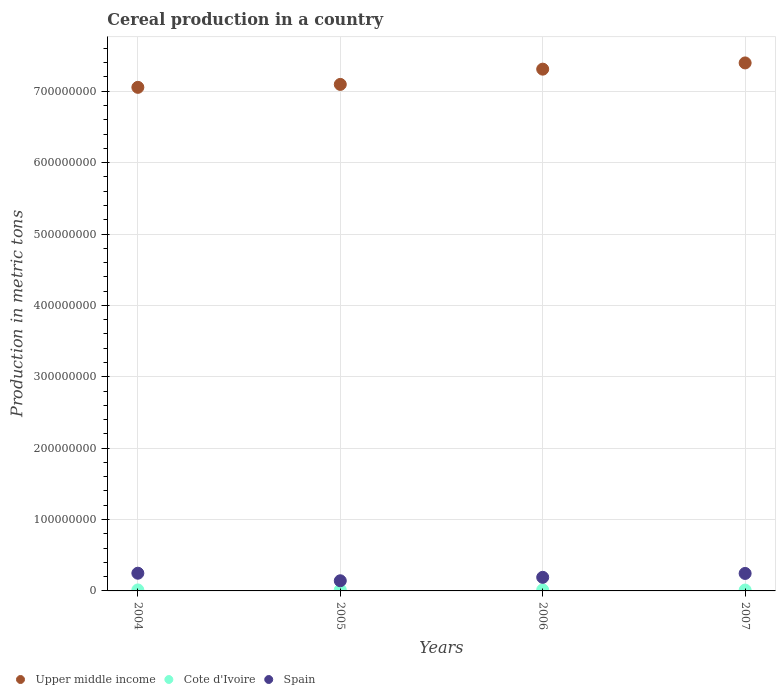What is the total cereal production in Upper middle income in 2005?
Provide a short and direct response. 7.10e+08. Across all years, what is the maximum total cereal production in Spain?
Offer a very short reply. 2.48e+07. Across all years, what is the minimum total cereal production in Spain?
Ensure brevity in your answer.  1.42e+07. In which year was the total cereal production in Upper middle income minimum?
Provide a short and direct response. 2004. What is the total total cereal production in Upper middle income in the graph?
Offer a very short reply. 2.89e+09. What is the difference between the total cereal production in Cote d'Ivoire in 2005 and that in 2007?
Give a very brief answer. 2.00e+05. What is the difference between the total cereal production in Upper middle income in 2004 and the total cereal production in Spain in 2005?
Your answer should be compact. 6.91e+08. What is the average total cereal production in Spain per year?
Your answer should be compact. 2.06e+07. In the year 2005, what is the difference between the total cereal production in Upper middle income and total cereal production in Cote d'Ivoire?
Provide a succinct answer. 7.08e+08. What is the ratio of the total cereal production in Spain in 2004 to that in 2006?
Your answer should be compact. 1.3. Is the difference between the total cereal production in Upper middle income in 2005 and 2006 greater than the difference between the total cereal production in Cote d'Ivoire in 2005 and 2006?
Offer a terse response. No. What is the difference between the highest and the second highest total cereal production in Upper middle income?
Provide a succinct answer. 8.72e+06. What is the difference between the highest and the lowest total cereal production in Upper middle income?
Offer a terse response. 3.42e+07. In how many years, is the total cereal production in Cote d'Ivoire greater than the average total cereal production in Cote d'Ivoire taken over all years?
Give a very brief answer. 3. Is the sum of the total cereal production in Spain in 2005 and 2007 greater than the maximum total cereal production in Cote d'Ivoire across all years?
Provide a short and direct response. Yes. Is the total cereal production in Cote d'Ivoire strictly greater than the total cereal production in Upper middle income over the years?
Offer a terse response. No. How many dotlines are there?
Your answer should be compact. 3. How many years are there in the graph?
Give a very brief answer. 4. Are the values on the major ticks of Y-axis written in scientific E-notation?
Offer a terse response. No. Does the graph contain grids?
Offer a very short reply. Yes. What is the title of the graph?
Provide a succinct answer. Cereal production in a country. What is the label or title of the Y-axis?
Provide a short and direct response. Production in metric tons. What is the Production in metric tons of Upper middle income in 2004?
Your response must be concise. 7.05e+08. What is the Production in metric tons in Cote d'Ivoire in 2004?
Provide a short and direct response. 1.38e+06. What is the Production in metric tons in Spain in 2004?
Keep it short and to the point. 2.48e+07. What is the Production in metric tons of Upper middle income in 2005?
Give a very brief answer. 7.10e+08. What is the Production in metric tons of Cote d'Ivoire in 2005?
Your answer should be very brief. 1.42e+06. What is the Production in metric tons in Spain in 2005?
Your answer should be very brief. 1.42e+07. What is the Production in metric tons in Upper middle income in 2006?
Offer a terse response. 7.31e+08. What is the Production in metric tons of Cote d'Ivoire in 2006?
Offer a very short reply. 1.44e+06. What is the Production in metric tons of Spain in 2006?
Make the answer very short. 1.90e+07. What is the Production in metric tons of Upper middle income in 2007?
Make the answer very short. 7.40e+08. What is the Production in metric tons of Cote d'Ivoire in 2007?
Provide a succinct answer. 1.22e+06. What is the Production in metric tons in Spain in 2007?
Ensure brevity in your answer.  2.45e+07. Across all years, what is the maximum Production in metric tons in Upper middle income?
Your response must be concise. 7.40e+08. Across all years, what is the maximum Production in metric tons of Cote d'Ivoire?
Offer a terse response. 1.44e+06. Across all years, what is the maximum Production in metric tons in Spain?
Your answer should be compact. 2.48e+07. Across all years, what is the minimum Production in metric tons in Upper middle income?
Keep it short and to the point. 7.05e+08. Across all years, what is the minimum Production in metric tons in Cote d'Ivoire?
Your answer should be compact. 1.22e+06. Across all years, what is the minimum Production in metric tons of Spain?
Provide a succinct answer. 1.42e+07. What is the total Production in metric tons of Upper middle income in the graph?
Your answer should be compact. 2.89e+09. What is the total Production in metric tons of Cote d'Ivoire in the graph?
Offer a very short reply. 5.47e+06. What is the total Production in metric tons of Spain in the graph?
Your answer should be very brief. 8.26e+07. What is the difference between the Production in metric tons of Upper middle income in 2004 and that in 2005?
Provide a short and direct response. -4.11e+06. What is the difference between the Production in metric tons in Cote d'Ivoire in 2004 and that in 2005?
Ensure brevity in your answer.  -4.68e+04. What is the difference between the Production in metric tons in Spain in 2004 and that in 2005?
Your answer should be compact. 1.06e+07. What is the difference between the Production in metric tons in Upper middle income in 2004 and that in 2006?
Keep it short and to the point. -2.55e+07. What is the difference between the Production in metric tons of Cote d'Ivoire in 2004 and that in 2006?
Provide a short and direct response. -6.37e+04. What is the difference between the Production in metric tons of Spain in 2004 and that in 2006?
Make the answer very short. 5.77e+06. What is the difference between the Production in metric tons in Upper middle income in 2004 and that in 2007?
Provide a short and direct response. -3.42e+07. What is the difference between the Production in metric tons of Cote d'Ivoire in 2004 and that in 2007?
Your answer should be compact. 1.54e+05. What is the difference between the Production in metric tons in Spain in 2004 and that in 2007?
Your response must be concise. 3.24e+05. What is the difference between the Production in metric tons of Upper middle income in 2005 and that in 2006?
Your answer should be very brief. -2.14e+07. What is the difference between the Production in metric tons of Cote d'Ivoire in 2005 and that in 2006?
Make the answer very short. -1.69e+04. What is the difference between the Production in metric tons of Spain in 2005 and that in 2006?
Make the answer very short. -4.81e+06. What is the difference between the Production in metric tons of Upper middle income in 2005 and that in 2007?
Your answer should be compact. -3.01e+07. What is the difference between the Production in metric tons in Cote d'Ivoire in 2005 and that in 2007?
Your answer should be compact. 2.00e+05. What is the difference between the Production in metric tons in Spain in 2005 and that in 2007?
Your answer should be compact. -1.03e+07. What is the difference between the Production in metric tons of Upper middle income in 2006 and that in 2007?
Provide a short and direct response. -8.72e+06. What is the difference between the Production in metric tons of Cote d'Ivoire in 2006 and that in 2007?
Provide a succinct answer. 2.17e+05. What is the difference between the Production in metric tons of Spain in 2006 and that in 2007?
Keep it short and to the point. -5.45e+06. What is the difference between the Production in metric tons of Upper middle income in 2004 and the Production in metric tons of Cote d'Ivoire in 2005?
Provide a succinct answer. 7.04e+08. What is the difference between the Production in metric tons of Upper middle income in 2004 and the Production in metric tons of Spain in 2005?
Your answer should be compact. 6.91e+08. What is the difference between the Production in metric tons in Cote d'Ivoire in 2004 and the Production in metric tons in Spain in 2005?
Provide a short and direct response. -1.28e+07. What is the difference between the Production in metric tons in Upper middle income in 2004 and the Production in metric tons in Cote d'Ivoire in 2006?
Your response must be concise. 7.04e+08. What is the difference between the Production in metric tons of Upper middle income in 2004 and the Production in metric tons of Spain in 2006?
Ensure brevity in your answer.  6.86e+08. What is the difference between the Production in metric tons in Cote d'Ivoire in 2004 and the Production in metric tons in Spain in 2006?
Keep it short and to the point. -1.77e+07. What is the difference between the Production in metric tons in Upper middle income in 2004 and the Production in metric tons in Cote d'Ivoire in 2007?
Provide a succinct answer. 7.04e+08. What is the difference between the Production in metric tons of Upper middle income in 2004 and the Production in metric tons of Spain in 2007?
Ensure brevity in your answer.  6.81e+08. What is the difference between the Production in metric tons of Cote d'Ivoire in 2004 and the Production in metric tons of Spain in 2007?
Offer a terse response. -2.31e+07. What is the difference between the Production in metric tons in Upper middle income in 2005 and the Production in metric tons in Cote d'Ivoire in 2006?
Provide a succinct answer. 7.08e+08. What is the difference between the Production in metric tons of Upper middle income in 2005 and the Production in metric tons of Spain in 2006?
Provide a succinct answer. 6.91e+08. What is the difference between the Production in metric tons of Cote d'Ivoire in 2005 and the Production in metric tons of Spain in 2006?
Ensure brevity in your answer.  -1.76e+07. What is the difference between the Production in metric tons in Upper middle income in 2005 and the Production in metric tons in Cote d'Ivoire in 2007?
Keep it short and to the point. 7.08e+08. What is the difference between the Production in metric tons in Upper middle income in 2005 and the Production in metric tons in Spain in 2007?
Provide a short and direct response. 6.85e+08. What is the difference between the Production in metric tons in Cote d'Ivoire in 2005 and the Production in metric tons in Spain in 2007?
Your response must be concise. -2.31e+07. What is the difference between the Production in metric tons of Upper middle income in 2006 and the Production in metric tons of Cote d'Ivoire in 2007?
Offer a very short reply. 7.30e+08. What is the difference between the Production in metric tons of Upper middle income in 2006 and the Production in metric tons of Spain in 2007?
Your answer should be compact. 7.06e+08. What is the difference between the Production in metric tons of Cote d'Ivoire in 2006 and the Production in metric tons of Spain in 2007?
Your response must be concise. -2.30e+07. What is the average Production in metric tons in Upper middle income per year?
Give a very brief answer. 7.21e+08. What is the average Production in metric tons in Cote d'Ivoire per year?
Your answer should be compact. 1.37e+06. What is the average Production in metric tons of Spain per year?
Provide a short and direct response. 2.06e+07. In the year 2004, what is the difference between the Production in metric tons in Upper middle income and Production in metric tons in Cote d'Ivoire?
Your answer should be very brief. 7.04e+08. In the year 2004, what is the difference between the Production in metric tons of Upper middle income and Production in metric tons of Spain?
Your answer should be very brief. 6.81e+08. In the year 2004, what is the difference between the Production in metric tons in Cote d'Ivoire and Production in metric tons in Spain?
Give a very brief answer. -2.34e+07. In the year 2005, what is the difference between the Production in metric tons of Upper middle income and Production in metric tons of Cote d'Ivoire?
Keep it short and to the point. 7.08e+08. In the year 2005, what is the difference between the Production in metric tons in Upper middle income and Production in metric tons in Spain?
Your response must be concise. 6.95e+08. In the year 2005, what is the difference between the Production in metric tons of Cote d'Ivoire and Production in metric tons of Spain?
Provide a short and direct response. -1.28e+07. In the year 2006, what is the difference between the Production in metric tons in Upper middle income and Production in metric tons in Cote d'Ivoire?
Offer a terse response. 7.29e+08. In the year 2006, what is the difference between the Production in metric tons in Upper middle income and Production in metric tons in Spain?
Your response must be concise. 7.12e+08. In the year 2006, what is the difference between the Production in metric tons in Cote d'Ivoire and Production in metric tons in Spain?
Provide a short and direct response. -1.76e+07. In the year 2007, what is the difference between the Production in metric tons of Upper middle income and Production in metric tons of Cote d'Ivoire?
Give a very brief answer. 7.38e+08. In the year 2007, what is the difference between the Production in metric tons of Upper middle income and Production in metric tons of Spain?
Keep it short and to the point. 7.15e+08. In the year 2007, what is the difference between the Production in metric tons of Cote d'Ivoire and Production in metric tons of Spain?
Your response must be concise. -2.33e+07. What is the ratio of the Production in metric tons of Cote d'Ivoire in 2004 to that in 2005?
Give a very brief answer. 0.97. What is the ratio of the Production in metric tons of Spain in 2004 to that in 2005?
Offer a very short reply. 1.74. What is the ratio of the Production in metric tons of Upper middle income in 2004 to that in 2006?
Ensure brevity in your answer.  0.97. What is the ratio of the Production in metric tons of Cote d'Ivoire in 2004 to that in 2006?
Your answer should be compact. 0.96. What is the ratio of the Production in metric tons in Spain in 2004 to that in 2006?
Your answer should be very brief. 1.3. What is the ratio of the Production in metric tons in Upper middle income in 2004 to that in 2007?
Ensure brevity in your answer.  0.95. What is the ratio of the Production in metric tons of Cote d'Ivoire in 2004 to that in 2007?
Give a very brief answer. 1.13. What is the ratio of the Production in metric tons in Spain in 2004 to that in 2007?
Your answer should be compact. 1.01. What is the ratio of the Production in metric tons in Upper middle income in 2005 to that in 2006?
Offer a very short reply. 0.97. What is the ratio of the Production in metric tons of Cote d'Ivoire in 2005 to that in 2006?
Your answer should be compact. 0.99. What is the ratio of the Production in metric tons in Spain in 2005 to that in 2006?
Your answer should be very brief. 0.75. What is the ratio of the Production in metric tons in Upper middle income in 2005 to that in 2007?
Keep it short and to the point. 0.96. What is the ratio of the Production in metric tons in Cote d'Ivoire in 2005 to that in 2007?
Provide a succinct answer. 1.16. What is the ratio of the Production in metric tons in Spain in 2005 to that in 2007?
Provide a succinct answer. 0.58. What is the ratio of the Production in metric tons in Cote d'Ivoire in 2006 to that in 2007?
Keep it short and to the point. 1.18. What is the ratio of the Production in metric tons in Spain in 2006 to that in 2007?
Make the answer very short. 0.78. What is the difference between the highest and the second highest Production in metric tons in Upper middle income?
Offer a terse response. 8.72e+06. What is the difference between the highest and the second highest Production in metric tons in Cote d'Ivoire?
Offer a terse response. 1.69e+04. What is the difference between the highest and the second highest Production in metric tons in Spain?
Your answer should be very brief. 3.24e+05. What is the difference between the highest and the lowest Production in metric tons in Upper middle income?
Give a very brief answer. 3.42e+07. What is the difference between the highest and the lowest Production in metric tons in Cote d'Ivoire?
Your answer should be very brief. 2.17e+05. What is the difference between the highest and the lowest Production in metric tons in Spain?
Keep it short and to the point. 1.06e+07. 